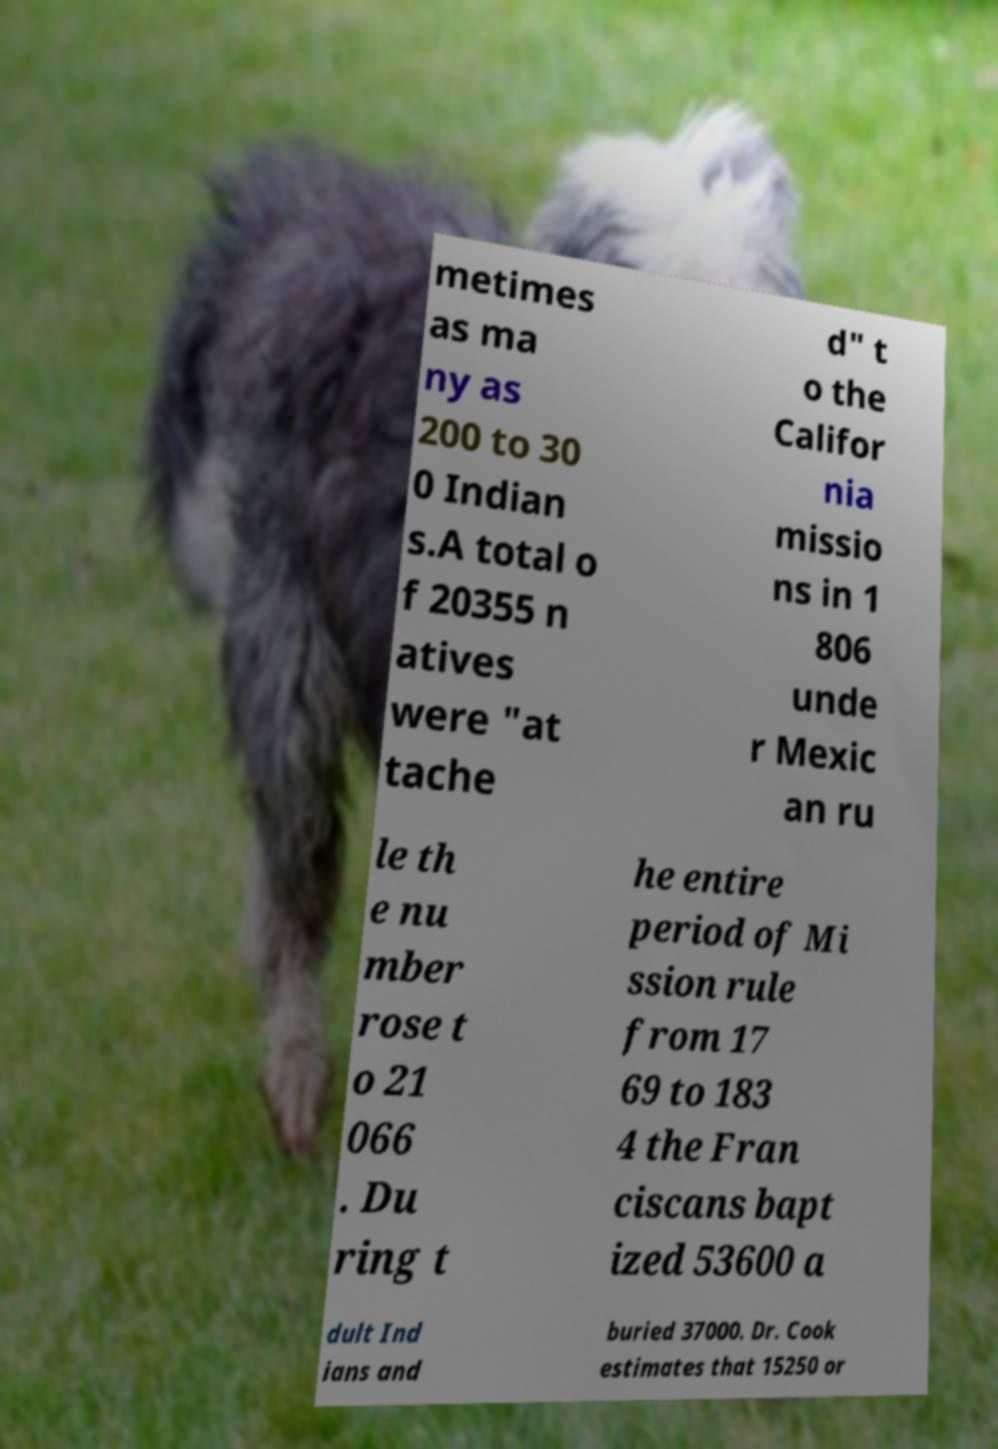Can you read and provide the text displayed in the image?This photo seems to have some interesting text. Can you extract and type it out for me? metimes as ma ny as 200 to 30 0 Indian s.A total o f 20355 n atives were "at tache d" t o the Califor nia missio ns in 1 806 unde r Mexic an ru le th e nu mber rose t o 21 066 . Du ring t he entire period of Mi ssion rule from 17 69 to 183 4 the Fran ciscans bapt ized 53600 a dult Ind ians and buried 37000. Dr. Cook estimates that 15250 or 